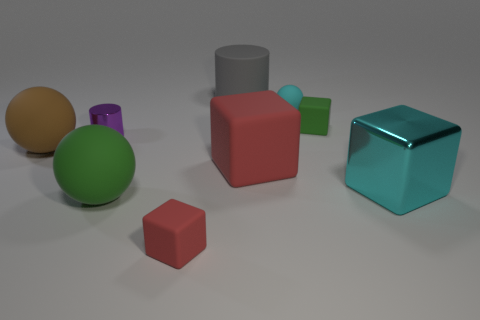Subtract all cyan blocks. How many blocks are left? 3 Subtract all gray spheres. How many red blocks are left? 2 Subtract all cyan cubes. How many cubes are left? 3 Subtract 1 balls. How many balls are left? 2 Add 1 green objects. How many objects exist? 10 Subtract all yellow cubes. Subtract all red balls. How many cubes are left? 4 Subtract all balls. How many objects are left? 6 Add 4 small matte blocks. How many small matte blocks are left? 6 Add 6 rubber cylinders. How many rubber cylinders exist? 7 Subtract 1 red cubes. How many objects are left? 8 